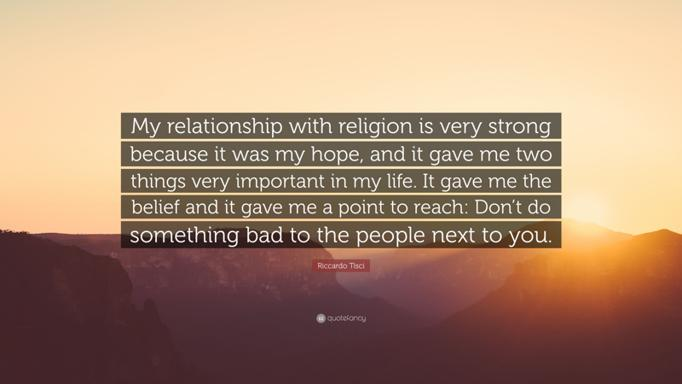What advice does the speaker give about interacting with people around them? The speaker advises maintaining ethical relations with those around you, succinctly highlighted by the guidance to avoid committing negative acts towards others. This counsel underscores the importance of personal responsibility and the impact of our actions on community well-being. 